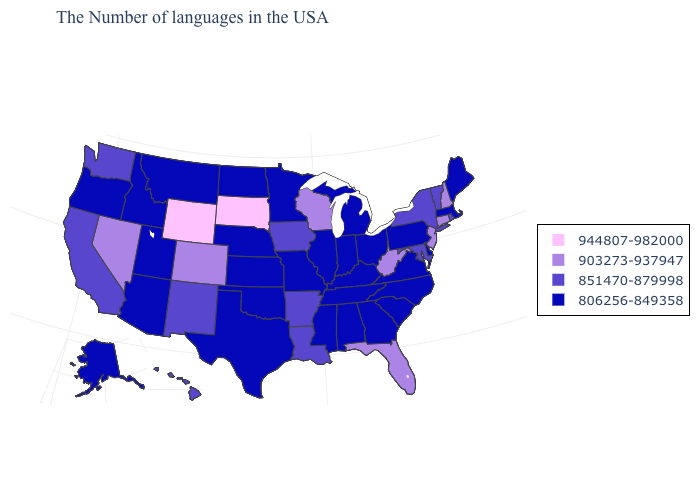Name the states that have a value in the range 806256-849358?
Short answer required. Maine, Massachusetts, Delaware, Pennsylvania, Virginia, North Carolina, South Carolina, Ohio, Georgia, Michigan, Kentucky, Indiana, Alabama, Tennessee, Illinois, Mississippi, Missouri, Minnesota, Kansas, Nebraska, Oklahoma, Texas, North Dakota, Utah, Montana, Arizona, Idaho, Oregon, Alaska. Does the map have missing data?
Short answer required. No. Which states hav the highest value in the MidWest?
Be succinct. South Dakota. Name the states that have a value in the range 903273-937947?
Concise answer only. New Hampshire, Connecticut, New Jersey, West Virginia, Florida, Wisconsin, Colorado, Nevada. Does Alaska have the lowest value in the West?
Quick response, please. Yes. Which states have the highest value in the USA?
Give a very brief answer. South Dakota, Wyoming. What is the highest value in states that border Oklahoma?
Concise answer only. 903273-937947. What is the value of Tennessee?
Answer briefly. 806256-849358. What is the highest value in the MidWest ?
Answer briefly. 944807-982000. Is the legend a continuous bar?
Give a very brief answer. No. What is the highest value in the MidWest ?
Be succinct. 944807-982000. Does the map have missing data?
Concise answer only. No. Does Idaho have the highest value in the West?
Concise answer only. No. Name the states that have a value in the range 903273-937947?
Concise answer only. New Hampshire, Connecticut, New Jersey, West Virginia, Florida, Wisconsin, Colorado, Nevada. Is the legend a continuous bar?
Keep it brief. No. 